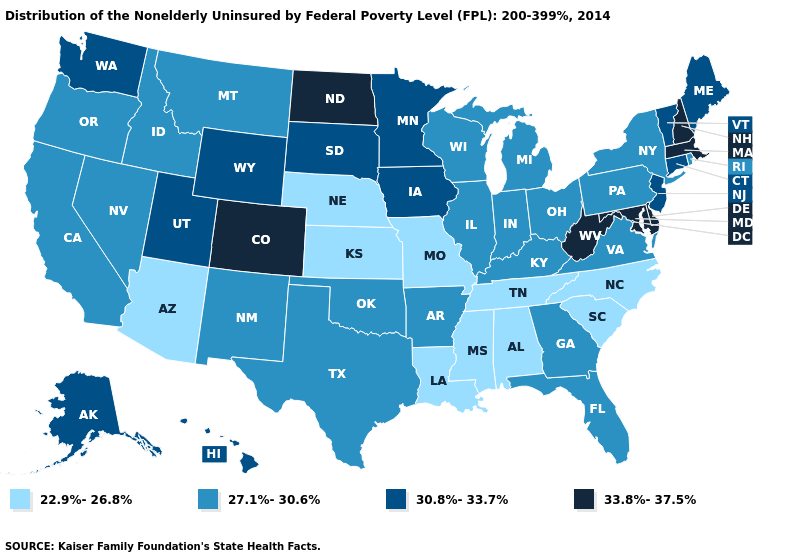What is the lowest value in the USA?
Short answer required. 22.9%-26.8%. Among the states that border New Mexico , does Colorado have the highest value?
Write a very short answer. Yes. What is the value of California?
Answer briefly. 27.1%-30.6%. Which states have the lowest value in the USA?
Write a very short answer. Alabama, Arizona, Kansas, Louisiana, Mississippi, Missouri, Nebraska, North Carolina, South Carolina, Tennessee. Does the map have missing data?
Write a very short answer. No. What is the value of Massachusetts?
Keep it brief. 33.8%-37.5%. What is the highest value in the USA?
Give a very brief answer. 33.8%-37.5%. Which states have the highest value in the USA?
Write a very short answer. Colorado, Delaware, Maryland, Massachusetts, New Hampshire, North Dakota, West Virginia. Name the states that have a value in the range 27.1%-30.6%?
Give a very brief answer. Arkansas, California, Florida, Georgia, Idaho, Illinois, Indiana, Kentucky, Michigan, Montana, Nevada, New Mexico, New York, Ohio, Oklahoma, Oregon, Pennsylvania, Rhode Island, Texas, Virginia, Wisconsin. Does Nevada have the lowest value in the West?
Short answer required. No. What is the value of Delaware?
Concise answer only. 33.8%-37.5%. Name the states that have a value in the range 22.9%-26.8%?
Short answer required. Alabama, Arizona, Kansas, Louisiana, Mississippi, Missouri, Nebraska, North Carolina, South Carolina, Tennessee. What is the highest value in the South ?
Answer briefly. 33.8%-37.5%. Does Louisiana have the lowest value in the USA?
Give a very brief answer. Yes. What is the lowest value in states that border Alabama?
Short answer required. 22.9%-26.8%. 